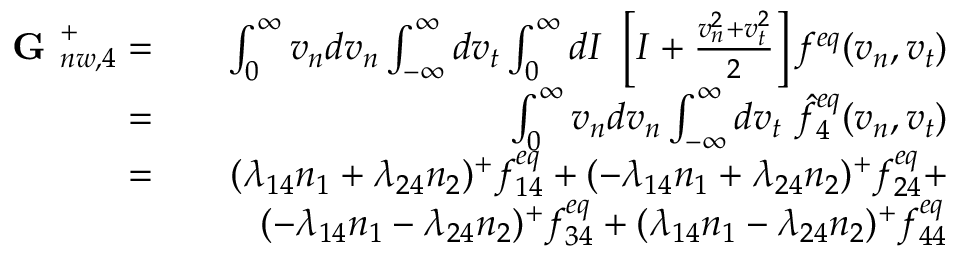<formula> <loc_0><loc_0><loc_500><loc_500>\begin{array} { r l r } { G _ { n w , 4 } ^ { + } = } & { \int _ { 0 } ^ { \infty } v _ { n } d v _ { n } \int _ { - \infty } ^ { \infty } d v _ { t } \int _ { 0 } ^ { \infty } d I \ \left [ I + \frac { v _ { n } ^ { 2 } + v _ { t } ^ { 2 } } { 2 } \right ] f ^ { e q } ( v _ { n } , v _ { t } ) } \\ { = } & { \int _ { 0 } ^ { \infty } v _ { n } d v _ { n } \int _ { - \infty } ^ { \infty } d v _ { t } \ \hat { f } _ { 4 } ^ { e q } ( v _ { n } , v _ { t } ) } \\ { = } & { ( \lambda _ { 1 4 } n _ { 1 } + \lambda _ { 2 4 } n _ { 2 } ) ^ { + } f _ { 1 4 } ^ { e q } + ( - \lambda _ { 1 4 } n _ { 1 } + \lambda _ { 2 4 } n _ { 2 } ) ^ { + } f _ { 2 4 } ^ { e q } + } \\ & { ( - \lambda _ { 1 4 } n _ { 1 } - \lambda _ { 2 4 } n _ { 2 } ) ^ { + } f _ { 3 4 } ^ { e q } + ( \lambda _ { 1 4 } n _ { 1 } - \lambda _ { 2 4 } n _ { 2 } ) ^ { + } f _ { 4 4 } ^ { e q } } \end{array}</formula> 